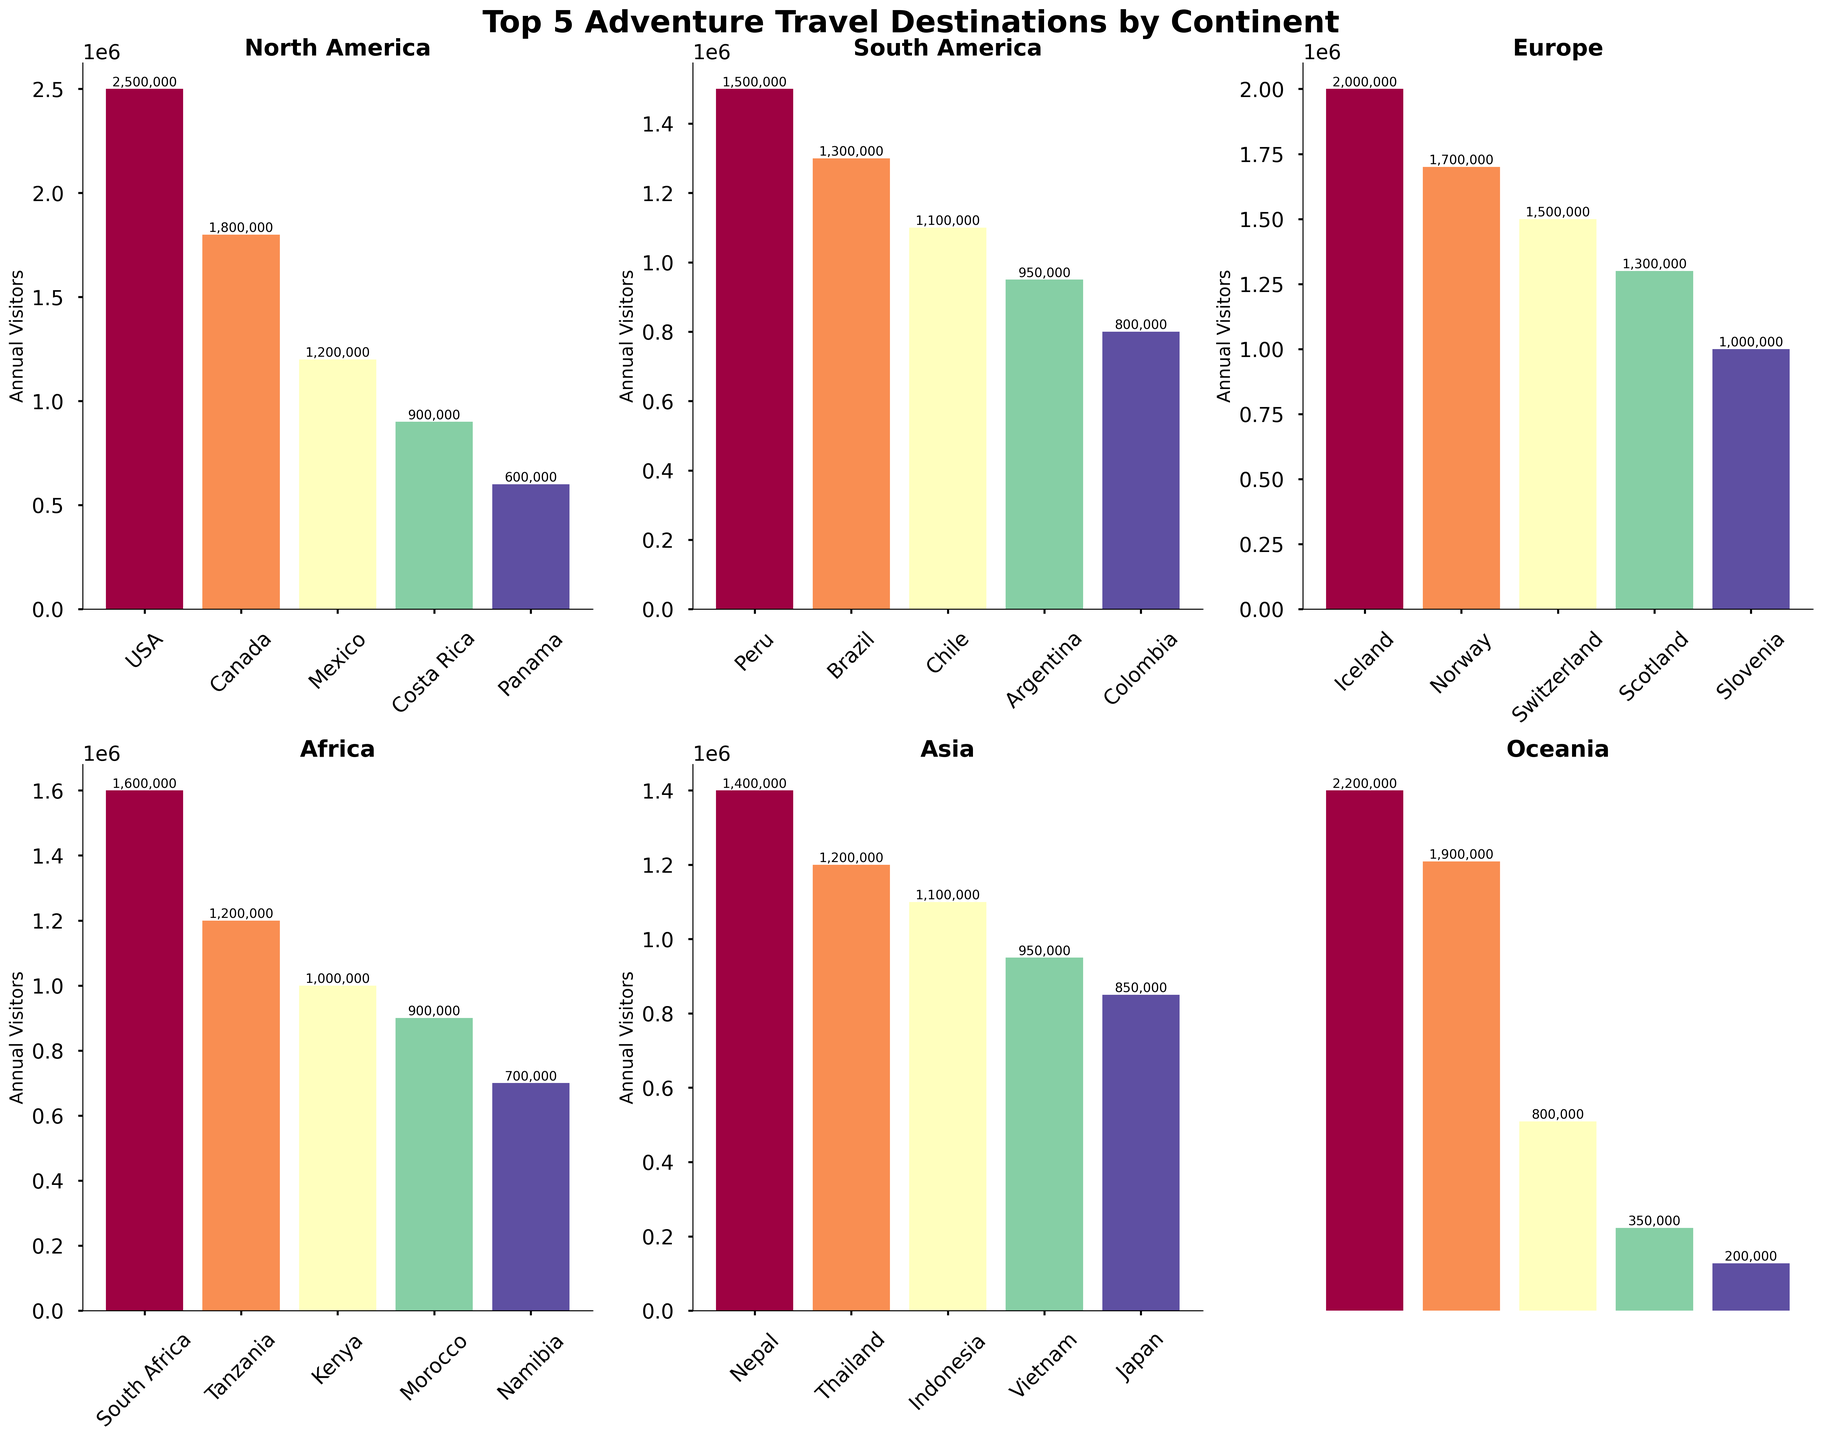Which country in Oceania has the highest number of annual visitors? Look at the bar chart for Oceania and compare the heights of the bars. The tallest bar represents New Zealand.
Answer: New Zealand Which has more annual visitors: Iceland or Peru? By how much? Compare the heights of the bars for Iceland (in Europe) and Peru (in South America). Iceland has 2,000,000 visitors, and Peru has 1,500,000 visitors. Subtract 1,500,000 from 2,000,000.
Answer: Iceland by 500,000 In Africa, which country has the second-highest number of visitors? In the Africa section, sort the bar heights in descending order. The second bar represents Tanzania.
Answer: Tanzania How many countries in Europe have more than 1.5 million annual visitors? Count the bars in the Europe section that exceed the 1.5 million mark. Iceland and Norway each have more than 1.5 million annual visitors.
Answer: 2 Which continent has the country with the fewest visitors, and what is the country's name? Compare the smallest bars in each continent. The smallest bar overall is in Oceania for Papua New Guinea, with 200,000 visitors.
Answer: Oceania, Papua New Guinea What is the difference in annual visitors between the leading countries in North America and Asia? Compare the bars for the USA in North America and Nepal in Asia. The USA has 2,500,000 visitors, and Nepal has 1,400,000 visitors. Subtract 1,400,000 from 2,500,000.
Answer: 1,100,000 Which has more annual visitors: Chile or Thailand? Compare the bar for Chile in South America with the bar for Thailand in Asia. Chile has 1,100,000 visitors, and Thailand has 1,200,000 visitors.
Answer: Thailand What is the average number of annual visitors for the top 5 countries in South America? Sum the visitors for the top 5 South American countries (1,500,000 + 1,300,000 + 1,100,000 + 950,000 + 800,000) and divide by 5. (5,650,000 / 5)
Answer: 1,130,000 